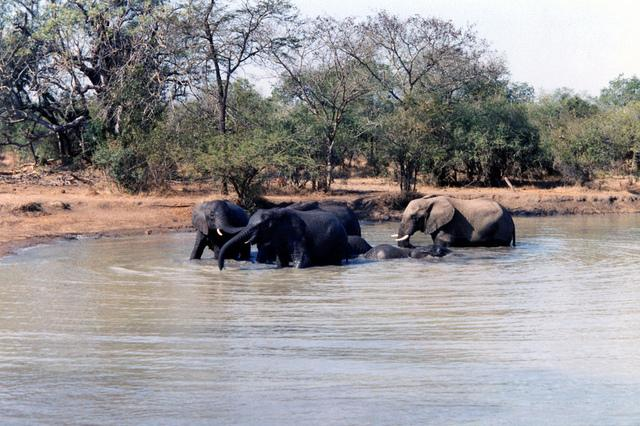Who has the last name that refers to what a group of these animals is called?

Choices:
A) curtis pride
B) jim herd
C) anna camp
D) tim crowder jim herd 